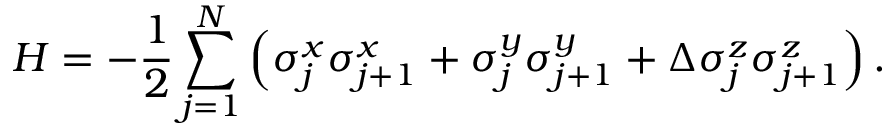Convert formula to latex. <formula><loc_0><loc_0><loc_500><loc_500>H = - \frac { 1 } { 2 } \sum _ { j = 1 } ^ { N } \left ( \sigma _ { j } ^ { x } \sigma _ { j + 1 } ^ { x } + \sigma _ { j } ^ { y } \sigma _ { j + 1 } ^ { y } + \Delta \sigma _ { j } ^ { z } \sigma _ { j + 1 } ^ { z } \right ) .</formula> 